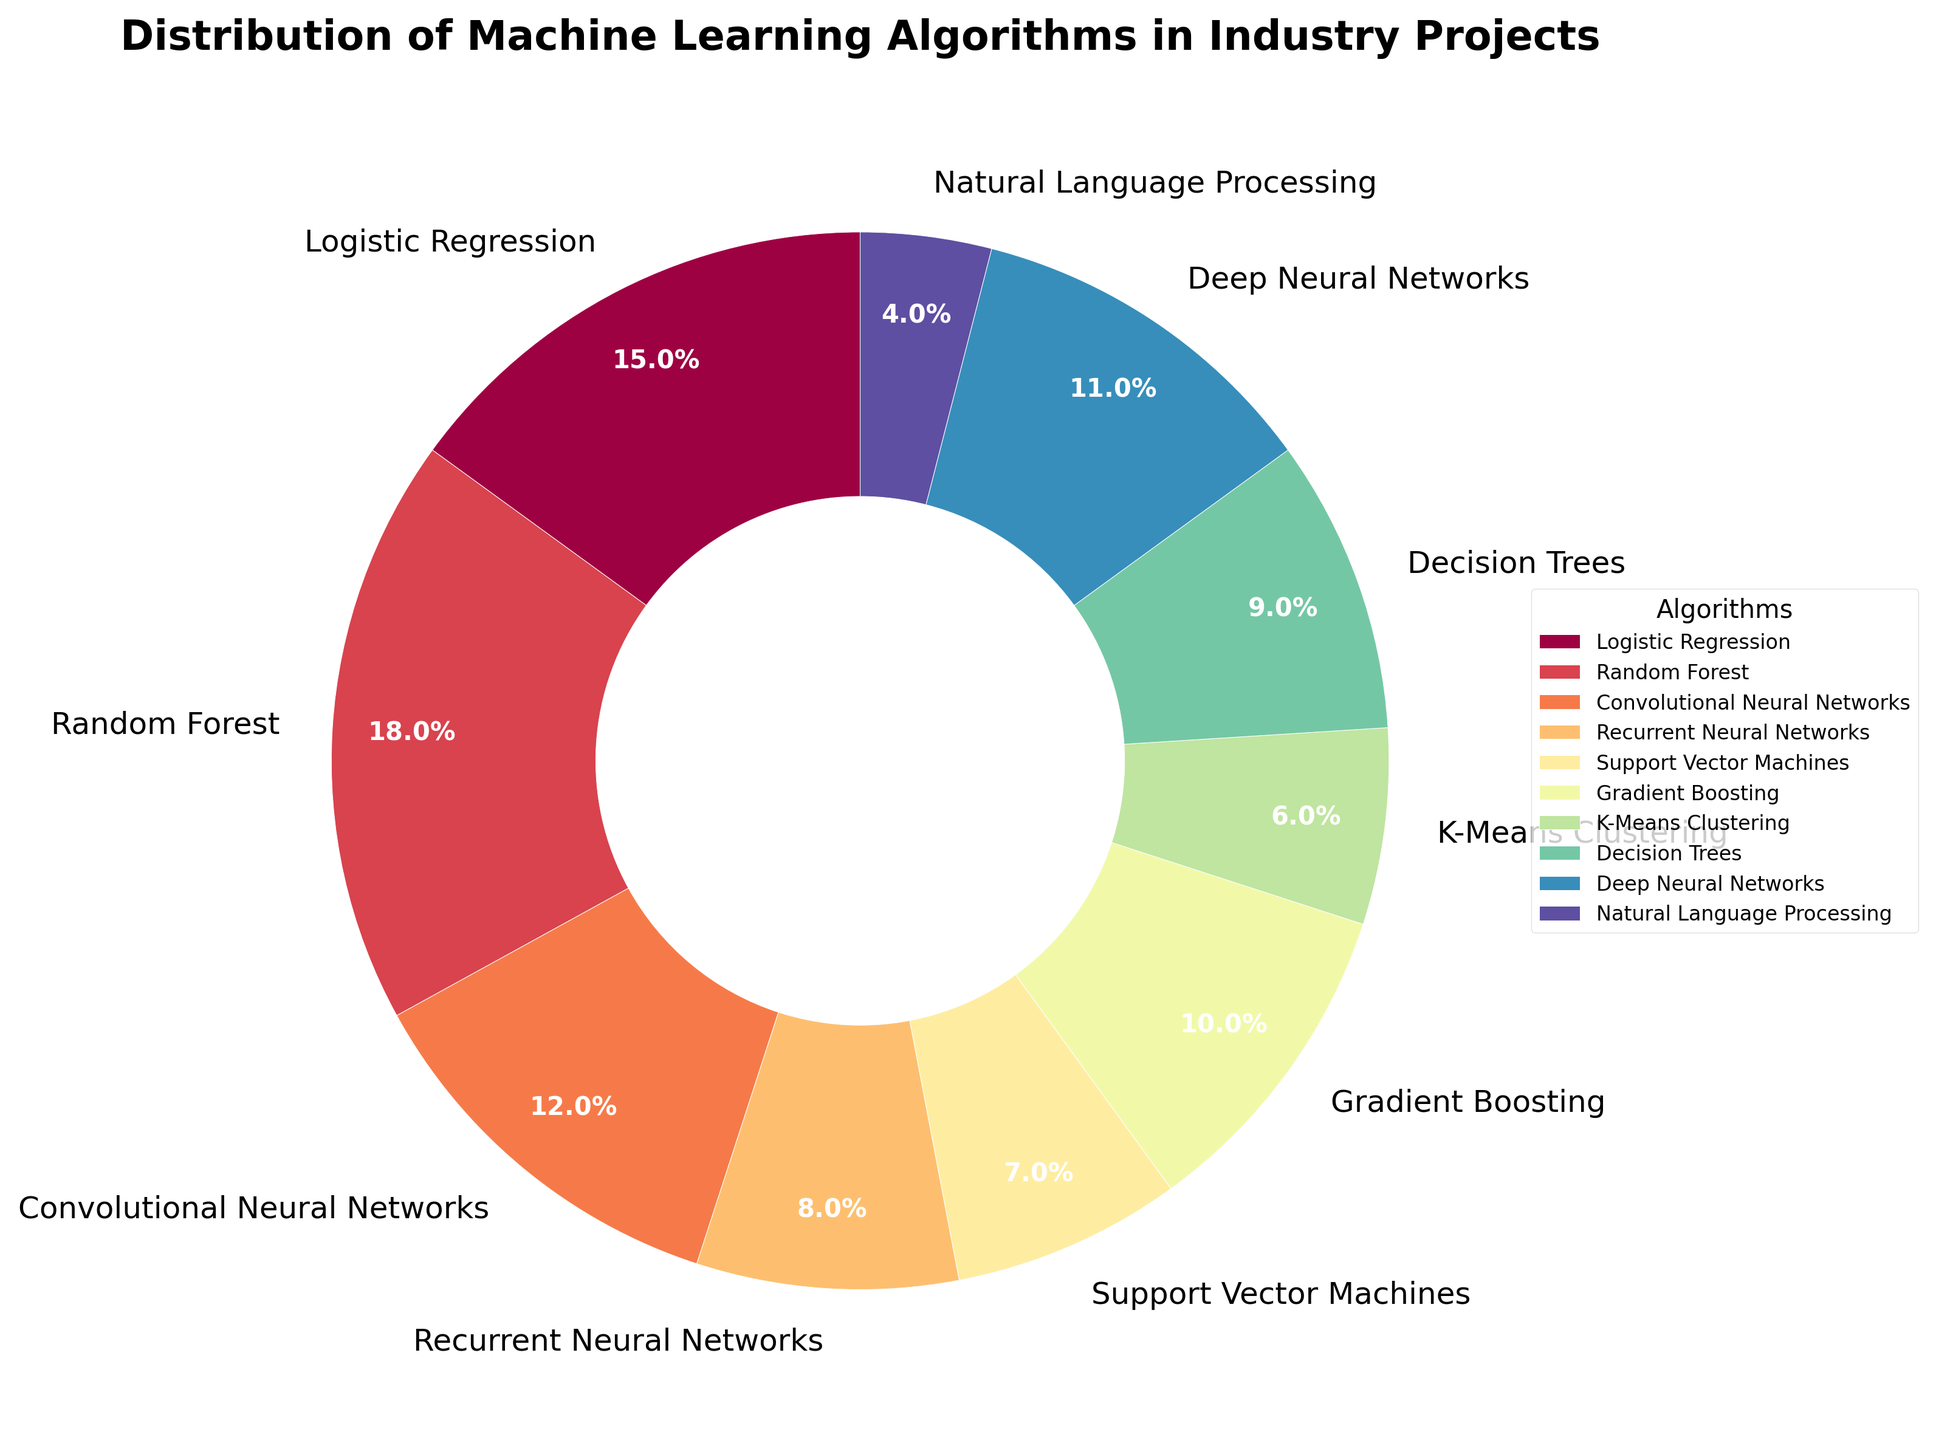What percentage of industry projects use Decision Trees? Locate the slice labeled "Decision Trees" in the pie chart. The label or the adjacent percentage value shows 9%.
Answer: 9% Which algorithm is used in more industry projects: Logistic Regression or Gradient Boosting? Compare the percentage values of "Logistic Regression" and "Gradient Boosting". Logistic Regression is 15%, and Gradient Boosting is 10%. Therefore, Logistic Regression is used more.
Answer: Logistic Regression What's the total percentage of industry projects using either Convolutional Neural Networks or Deep Neural Networks? Locate the percentage values for "Convolutional Neural Networks" (12%) and "Deep Neural Networks" (11%). Sum these values: 12 + 11 = 23%.
Answer: 23% How does the usage of K-Means Clustering compare to the usage of Support Vector Machines? Compare the percentage values of "K-Means Clustering" and "Support Vector Machines". K-Means Clustering is 6%, and Support Vector Machines is 7%. Therefore, K-Means Clustering is used less.
Answer: K-Means Clustering is used less List the algorithms that collectively make up more than half of the industry projects. Identify algorithms and their percentages. Start summing the largest values until the total exceeds 50%: Random Forest (18%) + Logistic Regression (15%) + Convolutional Neural Networks (12%) + Deep Neural Networks (11%) = 56%. So, these four algorithms collectively make up more than half.
Answer: Random Forest, Logistic Regression, Convolutional Neural Networks, Deep Neural Networks Which algorithm is represented by the lightest color on the pie chart? Identify the lightest color slice in the pie chart visually. The slice with the lightest color corresponds to Natural Language Processing.
Answer: Natural Language Processing What's the difference in percentage points between the most and least used algorithms? Find the highest (Random Forest, 18%) and lowest (Natural Language Processing, 4%) percentage values. Calculate the difference: 18 - 4 = 14 percentage points.
Answer: 14 percentage points Do the percentages for Recurrent Neural Networks and Decision Trees sum to more or less than the percentage for Random Forest? Locate the values for Recurrent Neural Networks (8%) and Decision Trees (9%), then sum them: 8 + 9 = 17%. Compare this with Random Forest (18%). The sum is less.
Answer: Less Which algorithms have a usage percentage in single digits? List algorithms with percentages less than 10%: Natural Language Processing (4%), K-Means Clustering (6%), Support Vector Machines (7%), and Recurrent Neural Networks (8%), Decision Trees (9%).
Answer: Natural Language Processing, K-Means Clustering, Support Vector Machines, Recurrent Neural Networks, Decision Trees What is the median usage percentage of the algorithms listed? List the percentages in ascending order: 4, 6, 7, 8, 9, 10, 11, 12, 15, 18. The median is the middle value in this sorted list, which is 10.
Answer: 10 